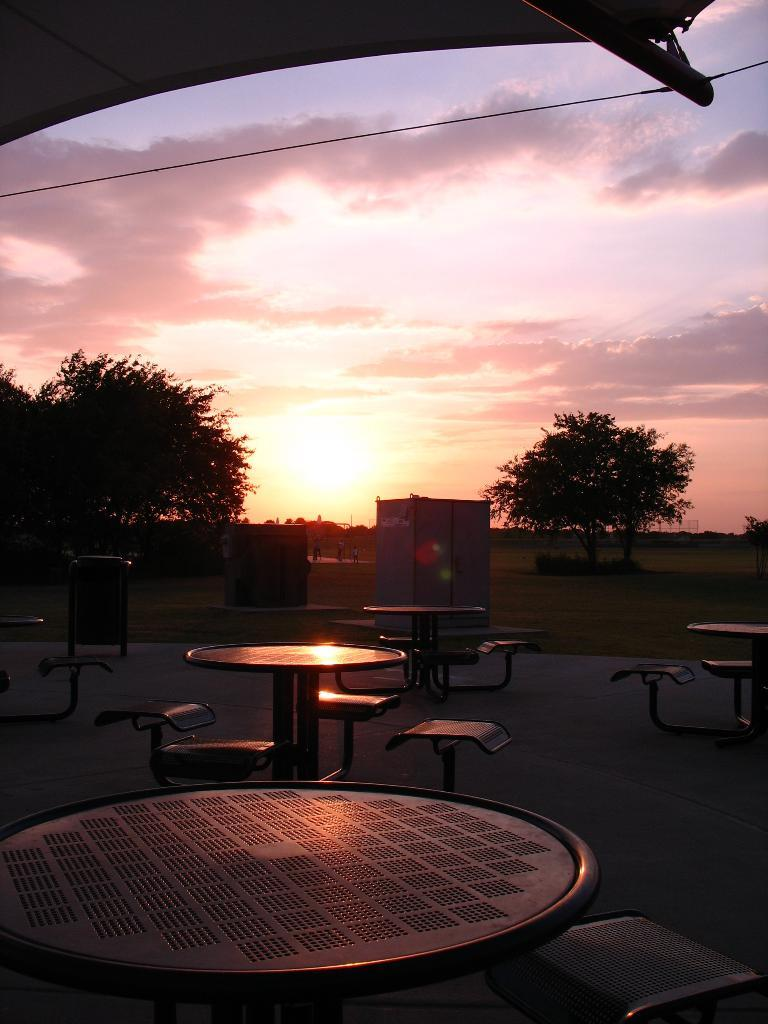What type of furniture is present in the image? There are chairs and tables in the image. What can be seen in the background of the image? There are tents and trees in the background of the image. What is the source of light in the image? Sunlight is visible in the image. How would you describe the color of the sky in the image? The sky is a combination of white and white and gray colors. How many frogs are sitting on the chairs in the image? There are no frogs present in the image. What type of zephyr can be seen blowing through the room in the image? There is no room or zephyr present in the image; it is an outdoor scene with tents and trees. 